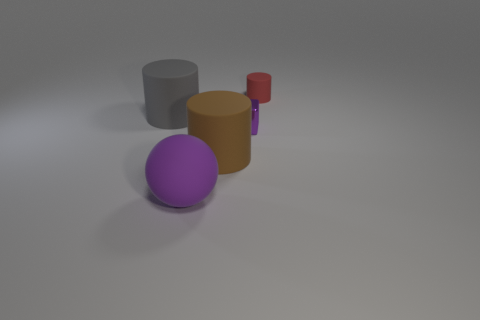Add 5 small red objects. How many objects exist? 10 Subtract all balls. How many objects are left? 4 Subtract all yellow metal spheres. Subtract all spheres. How many objects are left? 4 Add 4 purple objects. How many purple objects are left? 6 Add 5 small brown matte cylinders. How many small brown matte cylinders exist? 5 Subtract 0 brown cubes. How many objects are left? 5 